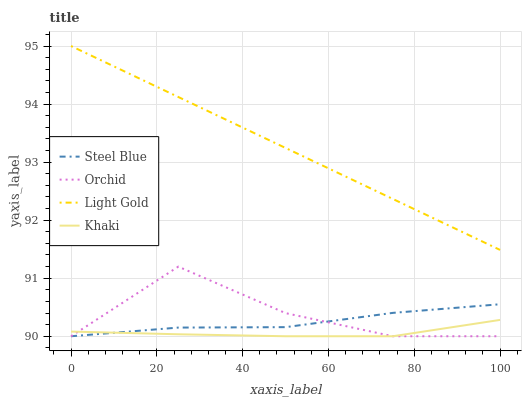Does Khaki have the minimum area under the curve?
Answer yes or no. Yes. Does Light Gold have the maximum area under the curve?
Answer yes or no. Yes. Does Steel Blue have the minimum area under the curve?
Answer yes or no. No. Does Steel Blue have the maximum area under the curve?
Answer yes or no. No. Is Light Gold the smoothest?
Answer yes or no. Yes. Is Orchid the roughest?
Answer yes or no. Yes. Is Steel Blue the smoothest?
Answer yes or no. No. Is Steel Blue the roughest?
Answer yes or no. No. Does Khaki have the lowest value?
Answer yes or no. Yes. Does Light Gold have the lowest value?
Answer yes or no. No. Does Light Gold have the highest value?
Answer yes or no. Yes. Does Steel Blue have the highest value?
Answer yes or no. No. Is Khaki less than Light Gold?
Answer yes or no. Yes. Is Light Gold greater than Khaki?
Answer yes or no. Yes. Does Khaki intersect Steel Blue?
Answer yes or no. Yes. Is Khaki less than Steel Blue?
Answer yes or no. No. Is Khaki greater than Steel Blue?
Answer yes or no. No. Does Khaki intersect Light Gold?
Answer yes or no. No. 